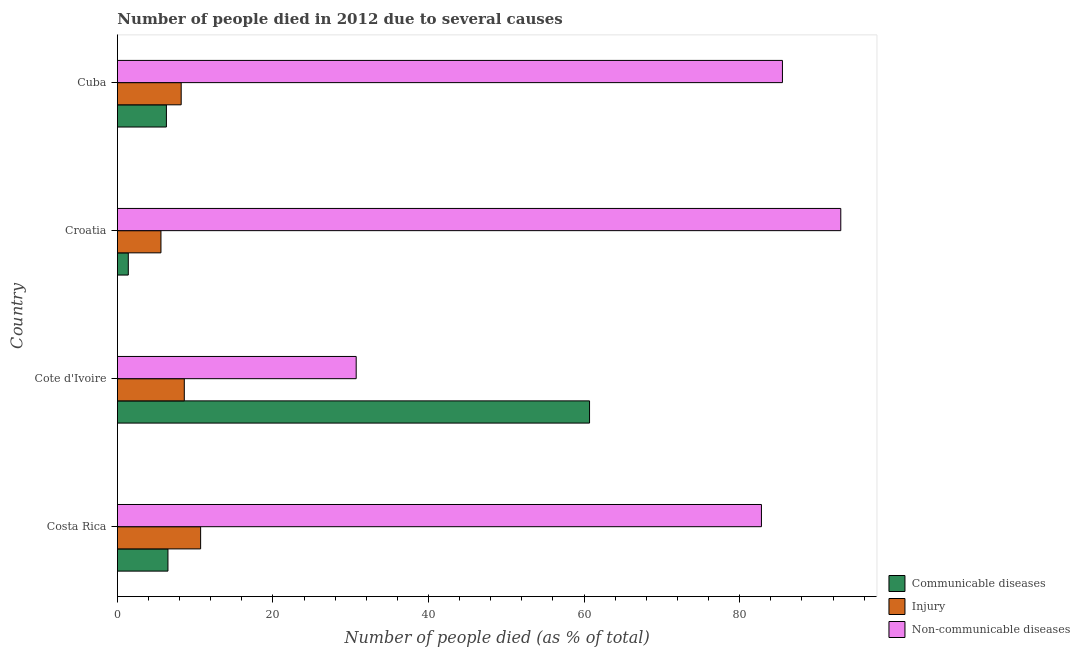How many different coloured bars are there?
Provide a short and direct response. 3. Are the number of bars per tick equal to the number of legend labels?
Offer a very short reply. Yes. Are the number of bars on each tick of the Y-axis equal?
Keep it short and to the point. Yes. How many bars are there on the 4th tick from the bottom?
Keep it short and to the point. 3. What is the label of the 2nd group of bars from the top?
Your answer should be very brief. Croatia. Across all countries, what is the minimum number of people who died of communicable diseases?
Your response must be concise. 1.4. In which country was the number of people who died of injury maximum?
Offer a very short reply. Costa Rica. In which country was the number of people who dies of non-communicable diseases minimum?
Ensure brevity in your answer.  Cote d'Ivoire. What is the total number of people who died of injury in the graph?
Keep it short and to the point. 33.1. What is the difference between the number of people who dies of non-communicable diseases in Cote d'Ivoire and that in Cuba?
Make the answer very short. -54.8. What is the difference between the number of people who died of injury in Croatia and the number of people who died of communicable diseases in Cuba?
Your answer should be very brief. -0.7. What is the average number of people who died of communicable diseases per country?
Your answer should be compact. 18.73. What is the difference between the number of people who dies of non-communicable diseases and number of people who died of communicable diseases in Costa Rica?
Keep it short and to the point. 76.3. In how many countries, is the number of people who died of injury greater than 40 %?
Offer a very short reply. 0. What is the ratio of the number of people who died of injury in Croatia to that in Cuba?
Make the answer very short. 0.68. Is the number of people who died of injury in Costa Rica less than that in Cote d'Ivoire?
Provide a short and direct response. No. Is the difference between the number of people who dies of non-communicable diseases in Costa Rica and Cuba greater than the difference between the number of people who died of communicable diseases in Costa Rica and Cuba?
Ensure brevity in your answer.  No. What is the difference between the highest and the second highest number of people who dies of non-communicable diseases?
Ensure brevity in your answer.  7.5. What is the difference between the highest and the lowest number of people who died of injury?
Your answer should be compact. 5.1. Is the sum of the number of people who died of communicable diseases in Costa Rica and Croatia greater than the maximum number of people who dies of non-communicable diseases across all countries?
Offer a very short reply. No. What does the 3rd bar from the top in Costa Rica represents?
Give a very brief answer. Communicable diseases. What does the 1st bar from the bottom in Cuba represents?
Provide a short and direct response. Communicable diseases. Is it the case that in every country, the sum of the number of people who died of communicable diseases and number of people who died of injury is greater than the number of people who dies of non-communicable diseases?
Offer a very short reply. No. How many bars are there?
Offer a very short reply. 12. Are all the bars in the graph horizontal?
Your answer should be compact. Yes. Where does the legend appear in the graph?
Ensure brevity in your answer.  Bottom right. What is the title of the graph?
Your answer should be very brief. Number of people died in 2012 due to several causes. Does "Unpaid family workers" appear as one of the legend labels in the graph?
Your response must be concise. No. What is the label or title of the X-axis?
Offer a very short reply. Number of people died (as % of total). What is the label or title of the Y-axis?
Your response must be concise. Country. What is the Number of people died (as % of total) of Communicable diseases in Costa Rica?
Offer a terse response. 6.5. What is the Number of people died (as % of total) of Injury in Costa Rica?
Give a very brief answer. 10.7. What is the Number of people died (as % of total) of Non-communicable diseases in Costa Rica?
Keep it short and to the point. 82.8. What is the Number of people died (as % of total) of Communicable diseases in Cote d'Ivoire?
Provide a succinct answer. 60.7. What is the Number of people died (as % of total) of Non-communicable diseases in Cote d'Ivoire?
Keep it short and to the point. 30.7. What is the Number of people died (as % of total) of Non-communicable diseases in Croatia?
Your response must be concise. 93. What is the Number of people died (as % of total) in Injury in Cuba?
Your response must be concise. 8.2. What is the Number of people died (as % of total) in Non-communicable diseases in Cuba?
Offer a terse response. 85.5. Across all countries, what is the maximum Number of people died (as % of total) of Communicable diseases?
Provide a succinct answer. 60.7. Across all countries, what is the maximum Number of people died (as % of total) in Non-communicable diseases?
Make the answer very short. 93. Across all countries, what is the minimum Number of people died (as % of total) in Non-communicable diseases?
Provide a succinct answer. 30.7. What is the total Number of people died (as % of total) of Communicable diseases in the graph?
Ensure brevity in your answer.  74.9. What is the total Number of people died (as % of total) in Injury in the graph?
Offer a terse response. 33.1. What is the total Number of people died (as % of total) in Non-communicable diseases in the graph?
Your response must be concise. 292. What is the difference between the Number of people died (as % of total) in Communicable diseases in Costa Rica and that in Cote d'Ivoire?
Your answer should be compact. -54.2. What is the difference between the Number of people died (as % of total) in Injury in Costa Rica and that in Cote d'Ivoire?
Keep it short and to the point. 2.1. What is the difference between the Number of people died (as % of total) in Non-communicable diseases in Costa Rica and that in Cote d'Ivoire?
Ensure brevity in your answer.  52.1. What is the difference between the Number of people died (as % of total) in Communicable diseases in Costa Rica and that in Croatia?
Give a very brief answer. 5.1. What is the difference between the Number of people died (as % of total) of Injury in Costa Rica and that in Croatia?
Offer a very short reply. 5.1. What is the difference between the Number of people died (as % of total) in Non-communicable diseases in Costa Rica and that in Croatia?
Your response must be concise. -10.2. What is the difference between the Number of people died (as % of total) of Communicable diseases in Costa Rica and that in Cuba?
Offer a very short reply. 0.2. What is the difference between the Number of people died (as % of total) in Non-communicable diseases in Costa Rica and that in Cuba?
Provide a succinct answer. -2.7. What is the difference between the Number of people died (as % of total) of Communicable diseases in Cote d'Ivoire and that in Croatia?
Your answer should be compact. 59.3. What is the difference between the Number of people died (as % of total) of Injury in Cote d'Ivoire and that in Croatia?
Your response must be concise. 3. What is the difference between the Number of people died (as % of total) in Non-communicable diseases in Cote d'Ivoire and that in Croatia?
Your response must be concise. -62.3. What is the difference between the Number of people died (as % of total) in Communicable diseases in Cote d'Ivoire and that in Cuba?
Make the answer very short. 54.4. What is the difference between the Number of people died (as % of total) in Non-communicable diseases in Cote d'Ivoire and that in Cuba?
Keep it short and to the point. -54.8. What is the difference between the Number of people died (as % of total) in Communicable diseases in Croatia and that in Cuba?
Keep it short and to the point. -4.9. What is the difference between the Number of people died (as % of total) of Non-communicable diseases in Croatia and that in Cuba?
Provide a short and direct response. 7.5. What is the difference between the Number of people died (as % of total) of Communicable diseases in Costa Rica and the Number of people died (as % of total) of Non-communicable diseases in Cote d'Ivoire?
Your answer should be compact. -24.2. What is the difference between the Number of people died (as % of total) in Injury in Costa Rica and the Number of people died (as % of total) in Non-communicable diseases in Cote d'Ivoire?
Your answer should be very brief. -20. What is the difference between the Number of people died (as % of total) of Communicable diseases in Costa Rica and the Number of people died (as % of total) of Injury in Croatia?
Give a very brief answer. 0.9. What is the difference between the Number of people died (as % of total) of Communicable diseases in Costa Rica and the Number of people died (as % of total) of Non-communicable diseases in Croatia?
Your answer should be compact. -86.5. What is the difference between the Number of people died (as % of total) in Injury in Costa Rica and the Number of people died (as % of total) in Non-communicable diseases in Croatia?
Provide a short and direct response. -82.3. What is the difference between the Number of people died (as % of total) of Communicable diseases in Costa Rica and the Number of people died (as % of total) of Injury in Cuba?
Your answer should be very brief. -1.7. What is the difference between the Number of people died (as % of total) of Communicable diseases in Costa Rica and the Number of people died (as % of total) of Non-communicable diseases in Cuba?
Offer a terse response. -79. What is the difference between the Number of people died (as % of total) in Injury in Costa Rica and the Number of people died (as % of total) in Non-communicable diseases in Cuba?
Provide a succinct answer. -74.8. What is the difference between the Number of people died (as % of total) in Communicable diseases in Cote d'Ivoire and the Number of people died (as % of total) in Injury in Croatia?
Your answer should be compact. 55.1. What is the difference between the Number of people died (as % of total) in Communicable diseases in Cote d'Ivoire and the Number of people died (as % of total) in Non-communicable diseases in Croatia?
Provide a succinct answer. -32.3. What is the difference between the Number of people died (as % of total) of Injury in Cote d'Ivoire and the Number of people died (as % of total) of Non-communicable diseases in Croatia?
Your answer should be compact. -84.4. What is the difference between the Number of people died (as % of total) in Communicable diseases in Cote d'Ivoire and the Number of people died (as % of total) in Injury in Cuba?
Your answer should be compact. 52.5. What is the difference between the Number of people died (as % of total) in Communicable diseases in Cote d'Ivoire and the Number of people died (as % of total) in Non-communicable diseases in Cuba?
Offer a terse response. -24.8. What is the difference between the Number of people died (as % of total) of Injury in Cote d'Ivoire and the Number of people died (as % of total) of Non-communicable diseases in Cuba?
Your answer should be very brief. -76.9. What is the difference between the Number of people died (as % of total) of Communicable diseases in Croatia and the Number of people died (as % of total) of Injury in Cuba?
Offer a very short reply. -6.8. What is the difference between the Number of people died (as % of total) of Communicable diseases in Croatia and the Number of people died (as % of total) of Non-communicable diseases in Cuba?
Offer a terse response. -84.1. What is the difference between the Number of people died (as % of total) in Injury in Croatia and the Number of people died (as % of total) in Non-communicable diseases in Cuba?
Your response must be concise. -79.9. What is the average Number of people died (as % of total) in Communicable diseases per country?
Make the answer very short. 18.73. What is the average Number of people died (as % of total) in Injury per country?
Keep it short and to the point. 8.28. What is the difference between the Number of people died (as % of total) of Communicable diseases and Number of people died (as % of total) of Injury in Costa Rica?
Offer a terse response. -4.2. What is the difference between the Number of people died (as % of total) of Communicable diseases and Number of people died (as % of total) of Non-communicable diseases in Costa Rica?
Give a very brief answer. -76.3. What is the difference between the Number of people died (as % of total) in Injury and Number of people died (as % of total) in Non-communicable diseases in Costa Rica?
Provide a short and direct response. -72.1. What is the difference between the Number of people died (as % of total) in Communicable diseases and Number of people died (as % of total) in Injury in Cote d'Ivoire?
Offer a very short reply. 52.1. What is the difference between the Number of people died (as % of total) in Communicable diseases and Number of people died (as % of total) in Non-communicable diseases in Cote d'Ivoire?
Keep it short and to the point. 30. What is the difference between the Number of people died (as % of total) of Injury and Number of people died (as % of total) of Non-communicable diseases in Cote d'Ivoire?
Provide a succinct answer. -22.1. What is the difference between the Number of people died (as % of total) in Communicable diseases and Number of people died (as % of total) in Non-communicable diseases in Croatia?
Your answer should be very brief. -91.6. What is the difference between the Number of people died (as % of total) in Injury and Number of people died (as % of total) in Non-communicable diseases in Croatia?
Give a very brief answer. -87.4. What is the difference between the Number of people died (as % of total) in Communicable diseases and Number of people died (as % of total) in Non-communicable diseases in Cuba?
Give a very brief answer. -79.2. What is the difference between the Number of people died (as % of total) of Injury and Number of people died (as % of total) of Non-communicable diseases in Cuba?
Offer a very short reply. -77.3. What is the ratio of the Number of people died (as % of total) of Communicable diseases in Costa Rica to that in Cote d'Ivoire?
Your response must be concise. 0.11. What is the ratio of the Number of people died (as % of total) of Injury in Costa Rica to that in Cote d'Ivoire?
Give a very brief answer. 1.24. What is the ratio of the Number of people died (as % of total) of Non-communicable diseases in Costa Rica to that in Cote d'Ivoire?
Your answer should be very brief. 2.7. What is the ratio of the Number of people died (as % of total) in Communicable diseases in Costa Rica to that in Croatia?
Your answer should be compact. 4.64. What is the ratio of the Number of people died (as % of total) of Injury in Costa Rica to that in Croatia?
Provide a short and direct response. 1.91. What is the ratio of the Number of people died (as % of total) of Non-communicable diseases in Costa Rica to that in Croatia?
Your answer should be very brief. 0.89. What is the ratio of the Number of people died (as % of total) of Communicable diseases in Costa Rica to that in Cuba?
Ensure brevity in your answer.  1.03. What is the ratio of the Number of people died (as % of total) of Injury in Costa Rica to that in Cuba?
Offer a terse response. 1.3. What is the ratio of the Number of people died (as % of total) of Non-communicable diseases in Costa Rica to that in Cuba?
Your answer should be very brief. 0.97. What is the ratio of the Number of people died (as % of total) in Communicable diseases in Cote d'Ivoire to that in Croatia?
Ensure brevity in your answer.  43.36. What is the ratio of the Number of people died (as % of total) in Injury in Cote d'Ivoire to that in Croatia?
Your response must be concise. 1.54. What is the ratio of the Number of people died (as % of total) of Non-communicable diseases in Cote d'Ivoire to that in Croatia?
Give a very brief answer. 0.33. What is the ratio of the Number of people died (as % of total) of Communicable diseases in Cote d'Ivoire to that in Cuba?
Offer a terse response. 9.63. What is the ratio of the Number of people died (as % of total) of Injury in Cote d'Ivoire to that in Cuba?
Your answer should be compact. 1.05. What is the ratio of the Number of people died (as % of total) in Non-communicable diseases in Cote d'Ivoire to that in Cuba?
Your answer should be compact. 0.36. What is the ratio of the Number of people died (as % of total) in Communicable diseases in Croatia to that in Cuba?
Offer a very short reply. 0.22. What is the ratio of the Number of people died (as % of total) of Injury in Croatia to that in Cuba?
Offer a very short reply. 0.68. What is the ratio of the Number of people died (as % of total) of Non-communicable diseases in Croatia to that in Cuba?
Offer a very short reply. 1.09. What is the difference between the highest and the second highest Number of people died (as % of total) of Communicable diseases?
Your answer should be very brief. 54.2. What is the difference between the highest and the second highest Number of people died (as % of total) in Injury?
Provide a short and direct response. 2.1. What is the difference between the highest and the lowest Number of people died (as % of total) of Communicable diseases?
Ensure brevity in your answer.  59.3. What is the difference between the highest and the lowest Number of people died (as % of total) of Non-communicable diseases?
Give a very brief answer. 62.3. 